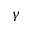<formula> <loc_0><loc_0><loc_500><loc_500>\gamma</formula> 